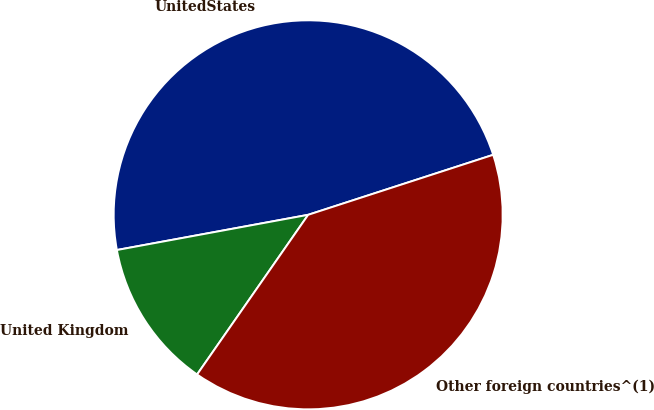<chart> <loc_0><loc_0><loc_500><loc_500><pie_chart><fcel>UnitedStates<fcel>United Kingdom<fcel>Other foreign countries^(1)<nl><fcel>47.91%<fcel>12.43%<fcel>39.67%<nl></chart> 